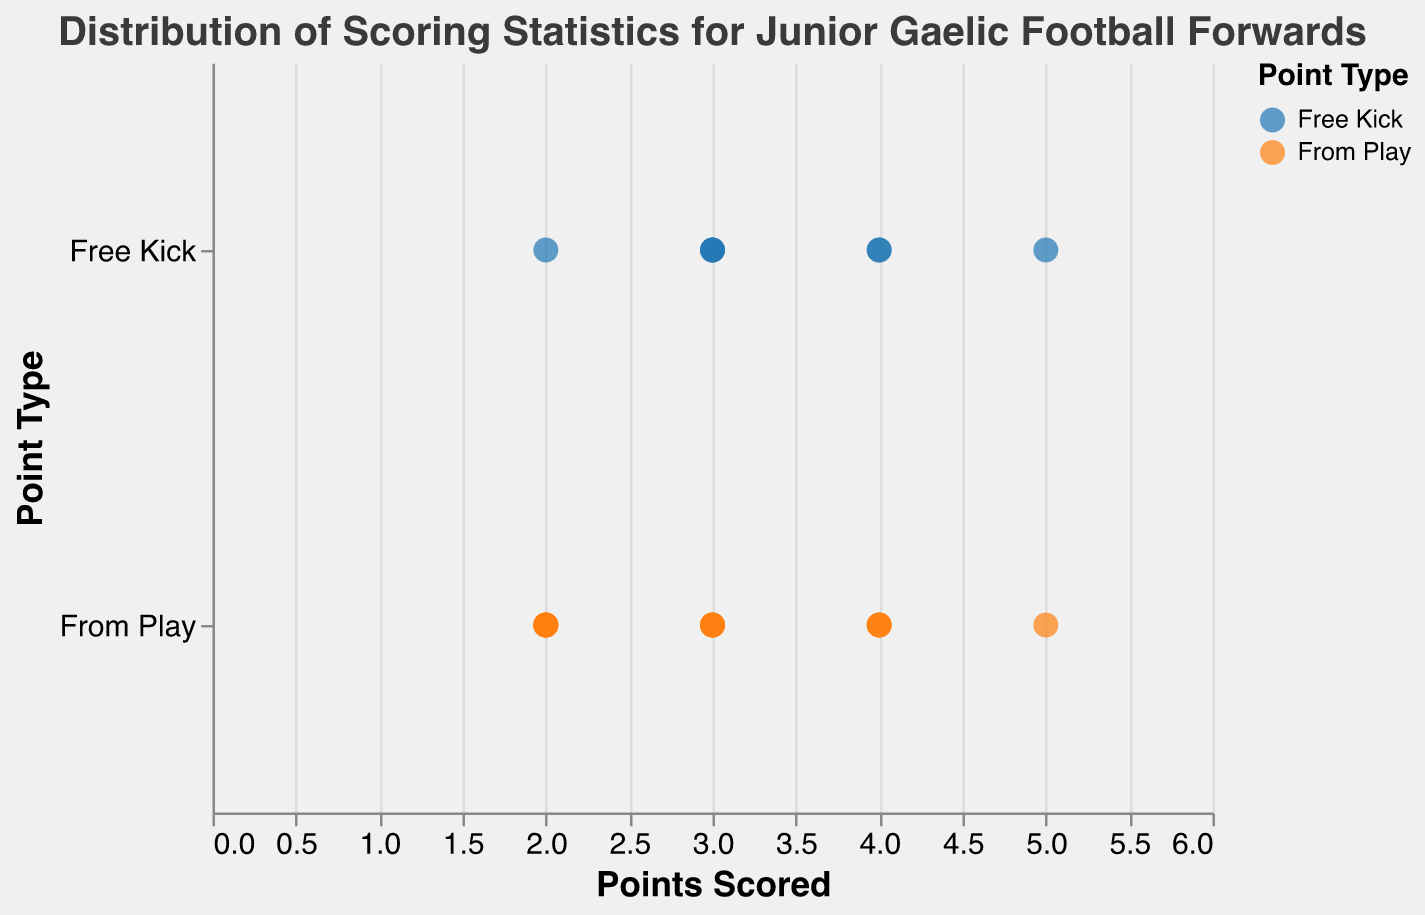What are the point types shown in the plot? The point types can be identified by looking at the y-axis labels. The axis shows the categories of point types.
Answer: Free Kick, From Play What is the range of points scored for "Free Kick" type? Look at the x-axis values for data points associated with "Free Kick". The minimum and maximum x-axis values among these points give the range.
Answer: 2 to 5 How many players scored 4 points "From Play"? Identify the data points for "From Play" type on the y-axis and then count those with x-axis value of 4.
Answer: 3 Who are the players that scored 3 points from "Free Kick"? Hover over or refer to the data points aligned with "Free Kick" and x-axis value of 3.
Answer: Sean O'Shea, Seanie O'Shea, Rian O'Neill What is the average score for points from "Free Kick"? Sum all the points for "Free Kick" and divide by the number of players: (3+2+4+5+3+3+4)/7 = 3.43
Answer: 3.43 What is the highest point scored from "From Play"? Find the maximum x-axis value for data points labeled "From Play".
Answer: 5 Are there more players with scores from "Free Kick" or "From Play"? Count the number of data points in both categories by looking at the y-axis.
Answer: From Play How many players scored exactly 2 points "From Play"? Count data points associated with "From Play" that have an x-axis value of 2.
Answer: 4 Which player scored the most points overall? Identify the highest data point on the x-axis and refer to the corresponding player. Dean Rock and David Clifford both have the highest score of 5.
Answer: Dean Rock, David Clifford Who scored 4 points "From Play"? Hover over or analyze the data points aligned with "From Play" and x-axis value 4.
Answer: Ciaran Kilkenny, Shane Walsh, Conor Sweeney 